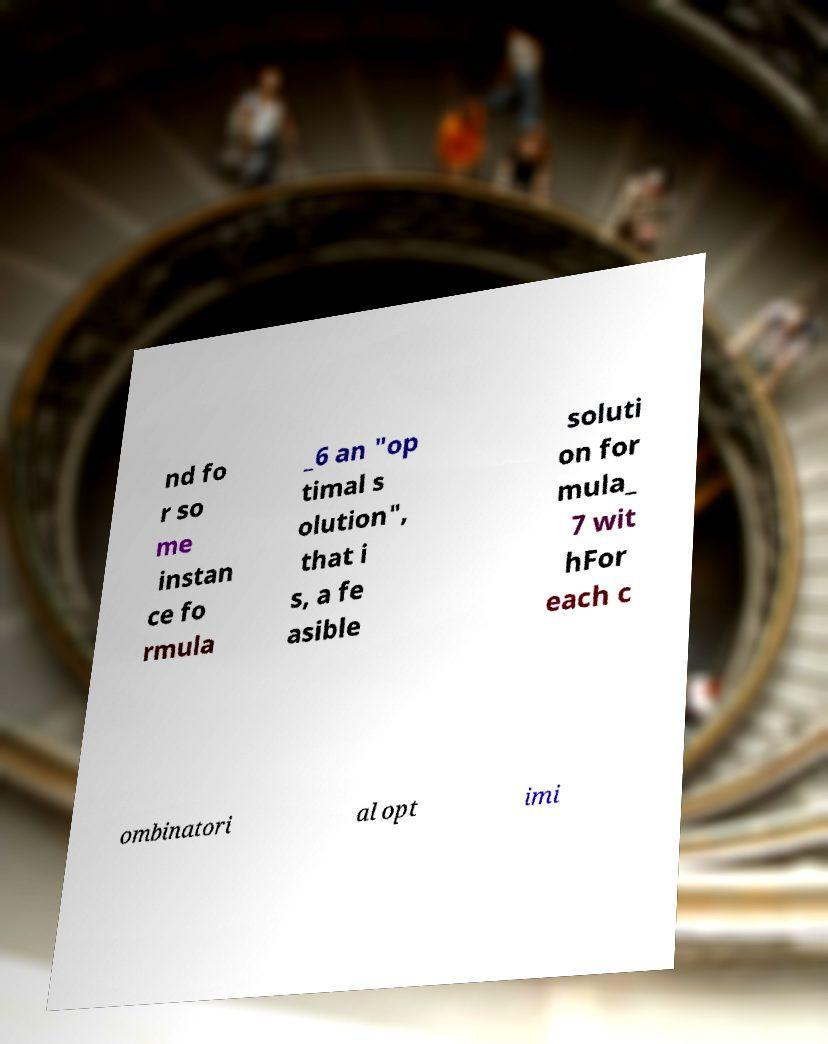Can you accurately transcribe the text from the provided image for me? nd fo r so me instan ce fo rmula _6 an "op timal s olution", that i s, a fe asible soluti on for mula_ 7 wit hFor each c ombinatori al opt imi 